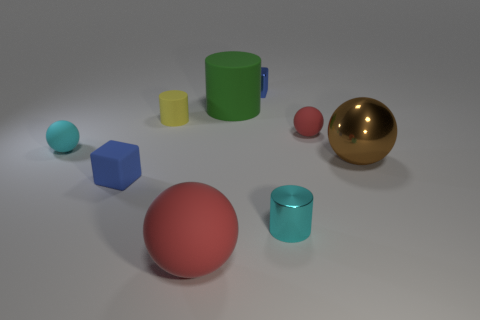Add 1 small cyan spheres. How many objects exist? 10 Subtract all spheres. How many objects are left? 5 Subtract all small rubber cubes. Subtract all small blue objects. How many objects are left? 6 Add 7 tiny yellow things. How many tiny yellow things are left? 8 Add 6 cyan spheres. How many cyan spheres exist? 7 Subtract 0 brown cylinders. How many objects are left? 9 